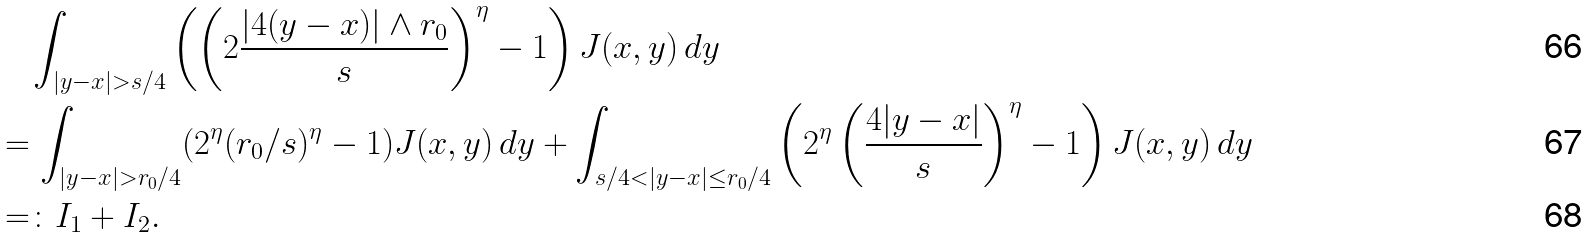<formula> <loc_0><loc_0><loc_500><loc_500>& \quad \int _ { | y - x | > s / 4 } \left ( \left ( 2 \frac { | 4 ( y - x ) | \wedge r _ { 0 } } { s } \right ) ^ { \eta } - 1 \right ) J ( x , y ) \, d y \\ & = \int _ { | y - x | > r _ { 0 } / 4 } ( 2 ^ { \eta } ( r _ { 0 } / s ) ^ { \eta } - 1 ) J ( x , y ) \, d y + \int _ { s / 4 < | y - x | \leq r _ { 0 } / 4 } \left ( 2 ^ { \eta } \left ( \frac { 4 | y - x | } { s } \right ) ^ { \eta } - 1 \right ) J ( x , y ) \, d y \\ & = \colon I _ { 1 } + I _ { 2 } .</formula> 